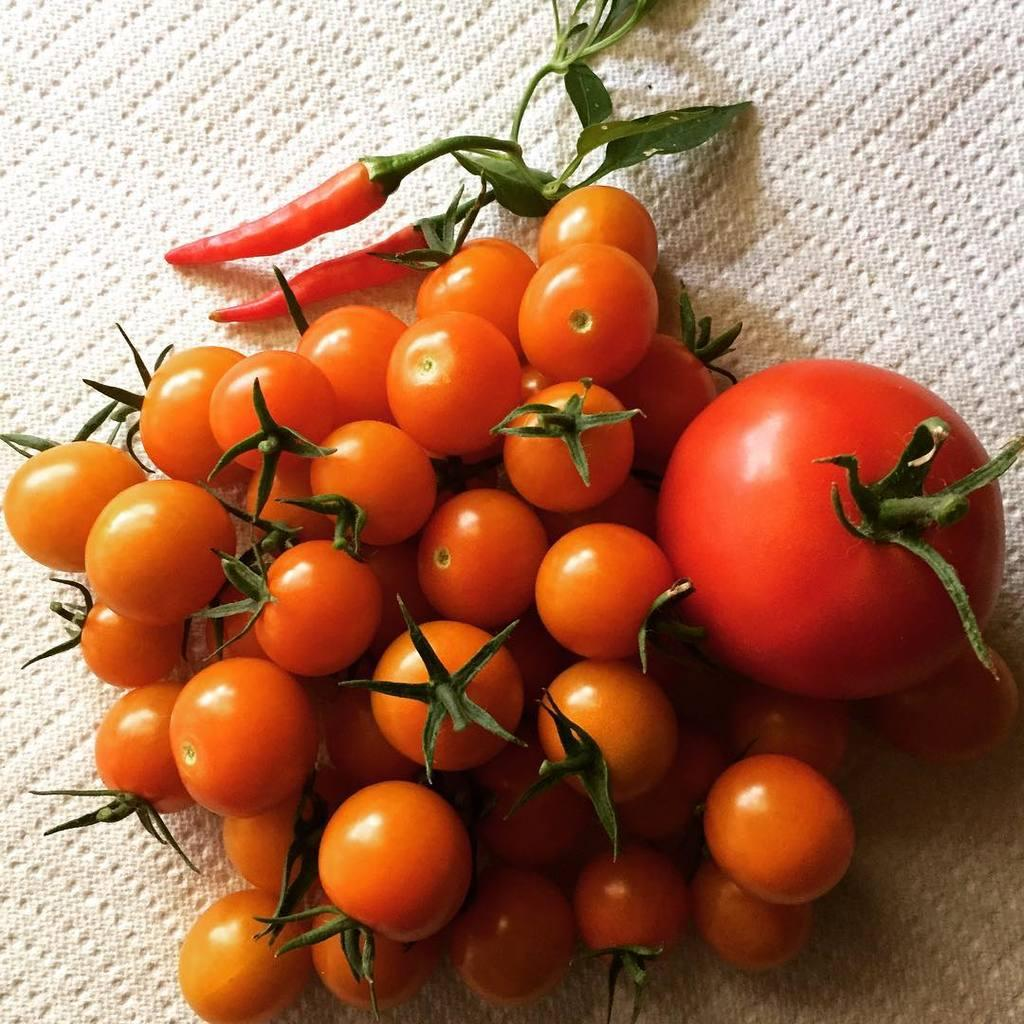What type of fruits are in the image? There are tomatoes in the image. What other type of food item is in the image? There are chilies in the image. On what are the tomatoes and chilies placed? The tomatoes and chilies are on a cloth. How many bananas can be seen hanging from the trees in the image? There are no bananas or trees present in the image. What type of range can be seen in the background of the image? There is no range visible in the image; it only features tomatoes and chilies on a cloth. 